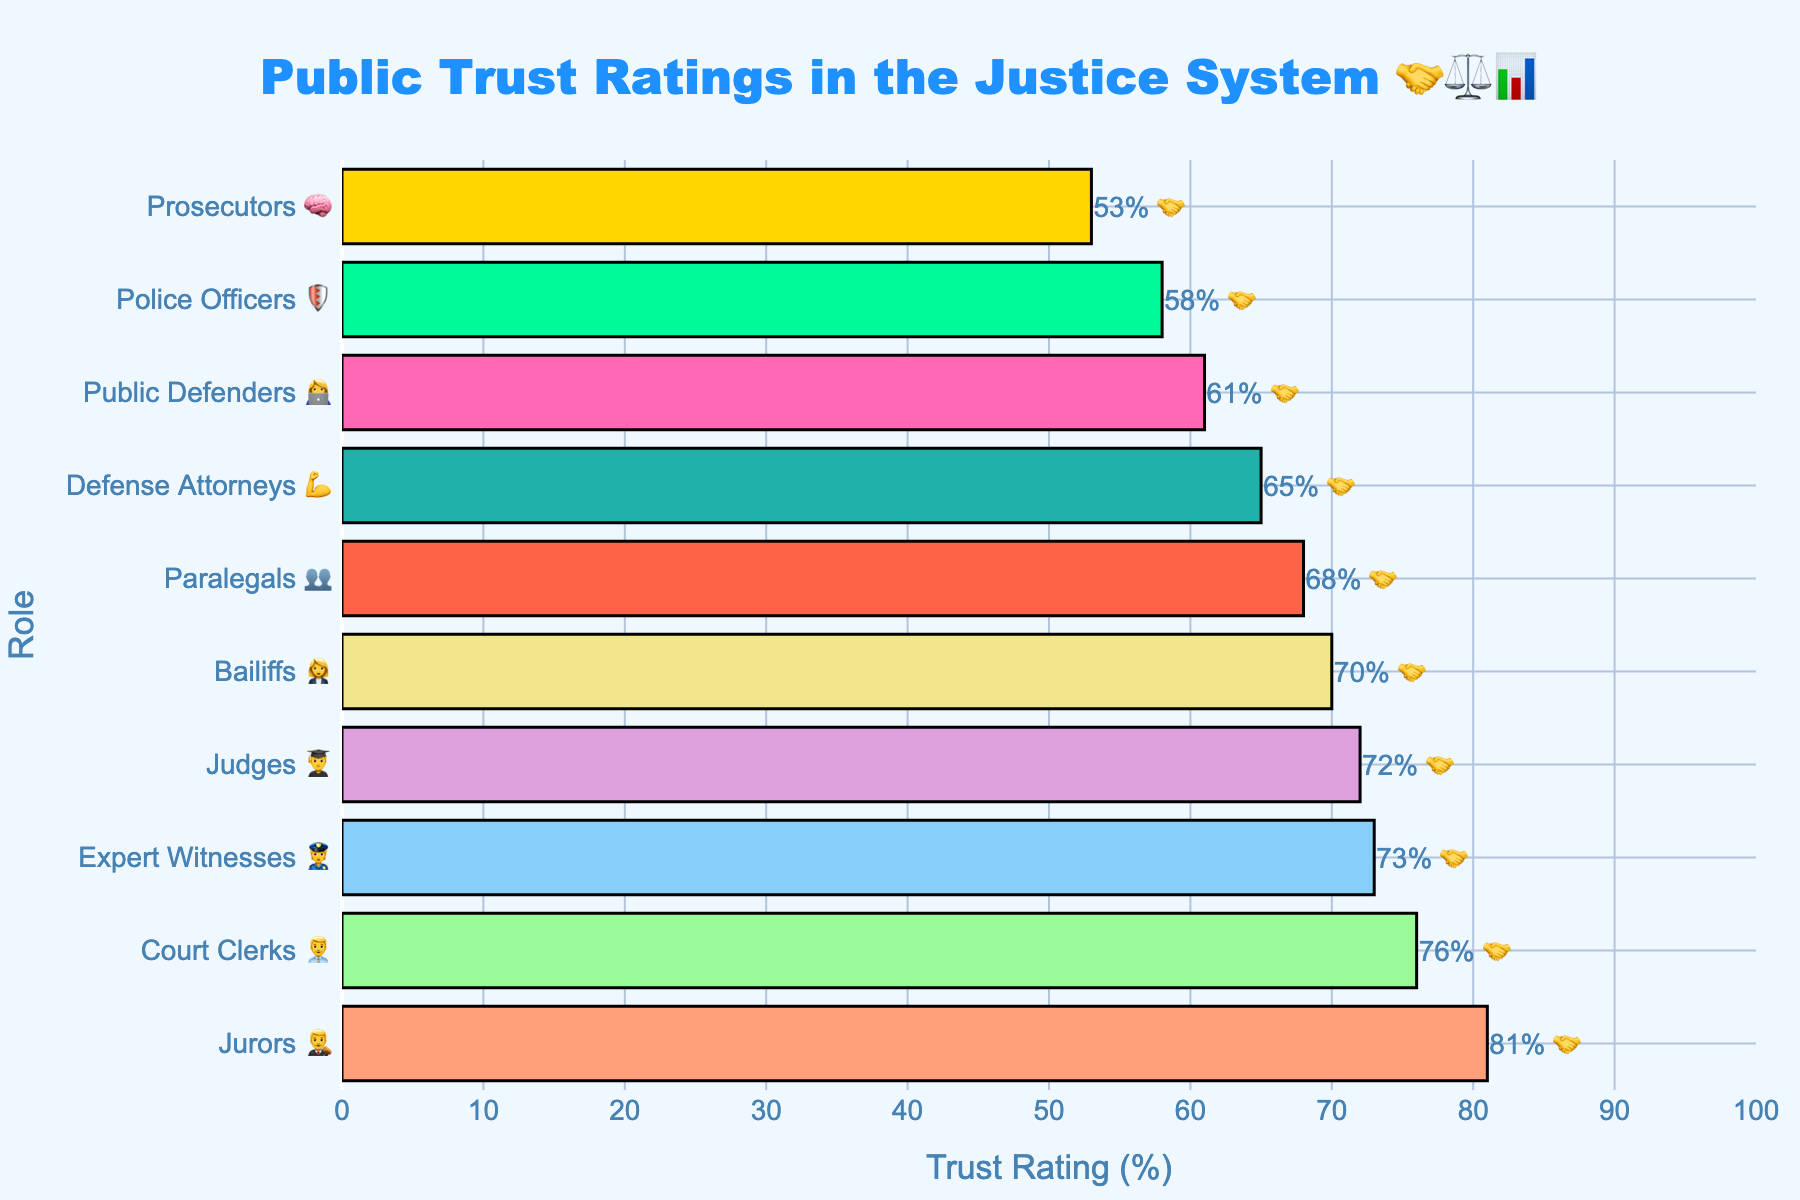What's the title of the chart? The title is displayed at the top of the chart and reads "Public Trust Ratings in the Justice System 🤝⚖️📊".
Answer: Public Trust Ratings in the Justice System 🤝⚖️📊 What are the trust ratings for prosecutors and defense attorneys? Look at the horizontal bars corresponding to "Prosecutors" and "Defense Attorneys". The ratings labeled next to these bars are 53% and 65%, respectively.
Answer: Prosecutors: 53%, Defense Attorneys: 65% Which role has the highest trust rating? Identify the role with the longest bar and the highest labeled percentage. The "Jurors" role has a trust rating of 81%.
Answer: Jurors What is the average trust rating of all roles? Sum up the trust ratings of all roles and divide by the number of roles (10). (72 + 65 + 58 + 53 + 76 + 81 + 70 + 68 + 61 + 73) / 10 = 67.7%
Answer: 67.7% How much higher is the trust rating for court clerks compared to prosecutors? Subtract the trust rating of prosecutors from that of court clerks. 76% (court clerks) - 53% (prosecutors) = 23%
Answer: 23% Which roles have trust ratings above the average rating? First, calculate the average trust rating (67.7%). Then look for roles with ratings above this value: Judges (72), Court Clerks (76), Jurors (81), Bailiffs (70), Expert Witnesses (73).
Answer: Judges, Court Clerks, Jurors, Bailiffs, Expert Witnesses Rank the top three roles by trust rating. Identify the three highest trust ratings and their corresponding roles. The order is: Jurors (81%), Court Clerks (76%), Expert Witnesses (73%).
Answer: 1. Jurors 2. Court Clerks 3. Expert Witnesses How does the trust rating of public defenders compare to that of paralegals? The trust rating of public defenders is 61%, while that of paralegals is 68%. Hence, paralegals have a higher trust rating by 7%.
Answer: Paralegals have a higher trust rating by 7% What is the difference in trust rating between police officers and defense attorneys? Subtract the trust rating of police officers from that of defense attorneys. 65% (defense attorneys) - 58% (police officers) = 7%.
Answer: 7% What role is associated with the 👩‍💼 emoji in the chart? Locate the role on the y-axis with the 👩‍💼 emoji next to it. The role "Court Clerks" is associated with this emoji.
Answer: Court Clerks 